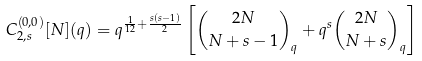<formula> <loc_0><loc_0><loc_500><loc_500>C ^ { ( 0 , 0 ) } _ { 2 , s } [ N ] ( q ) = q ^ { \frac { 1 } { 1 2 } + \frac { s ( s - 1 ) } { 2 } } \left [ { 2 N \choose N + s - 1 } _ { q } + q ^ { s } { 2 N \choose N + s } _ { q } \right ]</formula> 